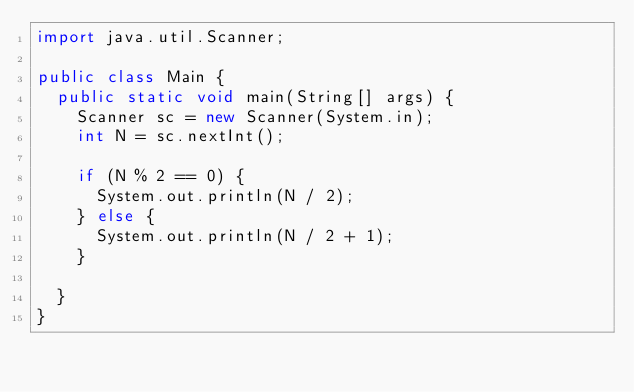<code> <loc_0><loc_0><loc_500><loc_500><_Java_>import java.util.Scanner;

public class Main {
	public static void main(String[] args) {
		Scanner sc = new Scanner(System.in);
		int N = sc.nextInt();

		if (N % 2 == 0) {
			System.out.println(N / 2);
		} else {
			System.out.println(N / 2 + 1);
		}

	}
}</code> 